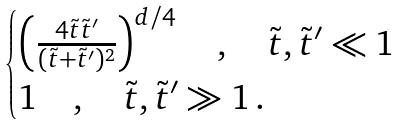<formula> <loc_0><loc_0><loc_500><loc_500>\begin{cases} \left ( \frac { 4 \tilde { t } \tilde { t } ^ { \prime } } { ( \tilde { t } + \tilde { t } ^ { \prime } ) ^ { 2 } } \right ) ^ { d / 4 } \quad , \quad \tilde { t } , \tilde { t } ^ { \prime } \ll 1 \\ 1 \quad , \quad \tilde { t } , \tilde { t } ^ { \prime } \gg 1 \, . \end{cases}</formula> 